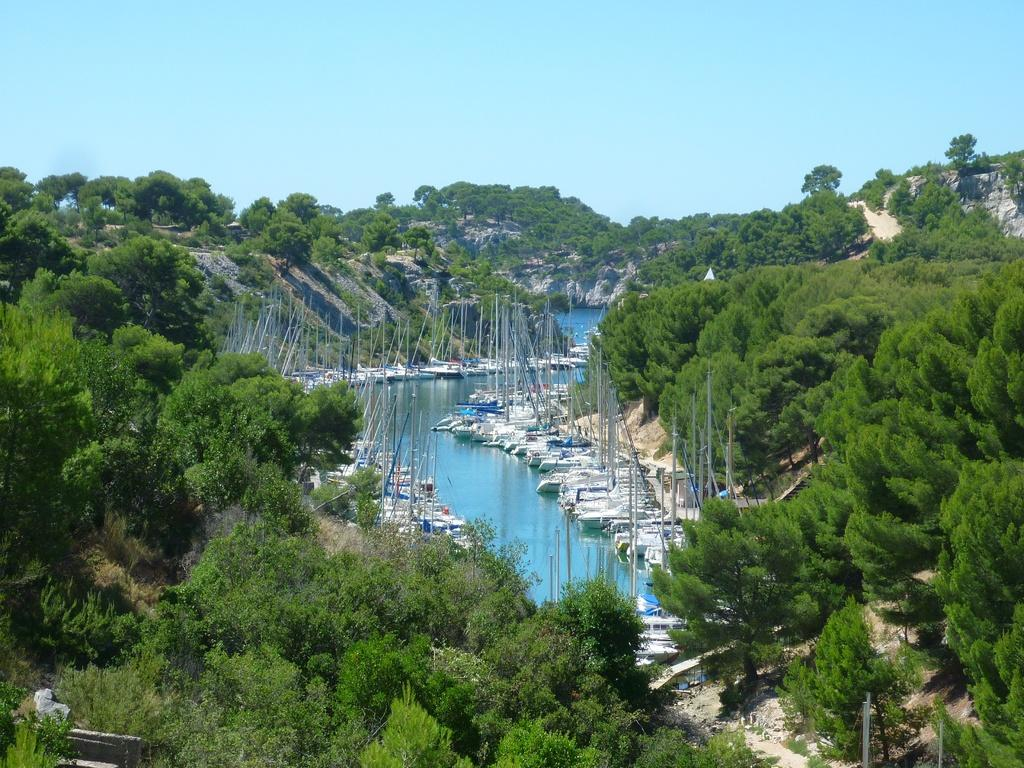What is on the water in the image? There are boats on the water in the image. What can be seen beside the boats? There are trees beside the boats. What is visible in the background of the image? There are hills visible in the background of the image. What type of brake system is installed on the boats in the image? There is no information about a brake system on the boats in the image, as boats typically do not have brakes. 